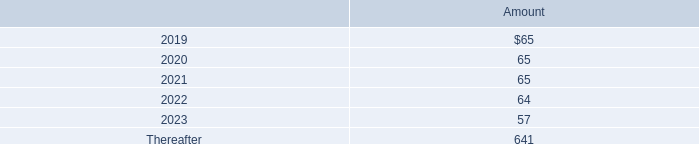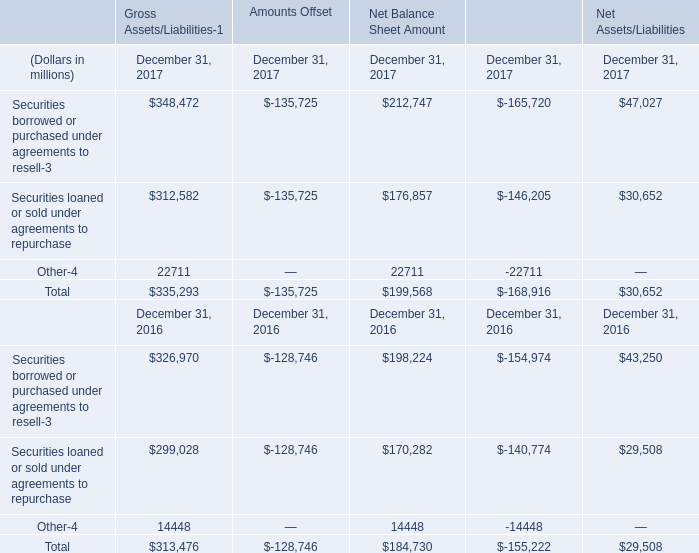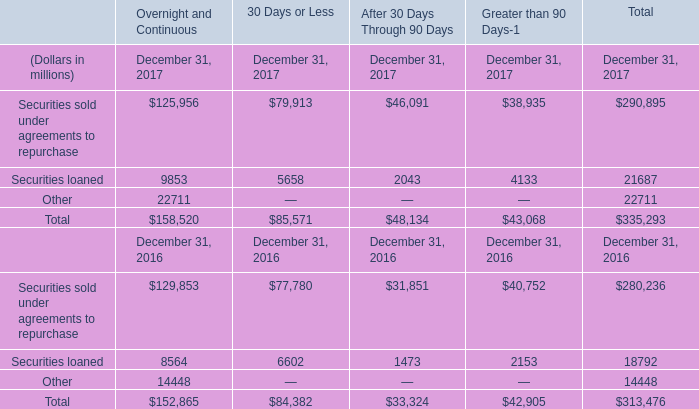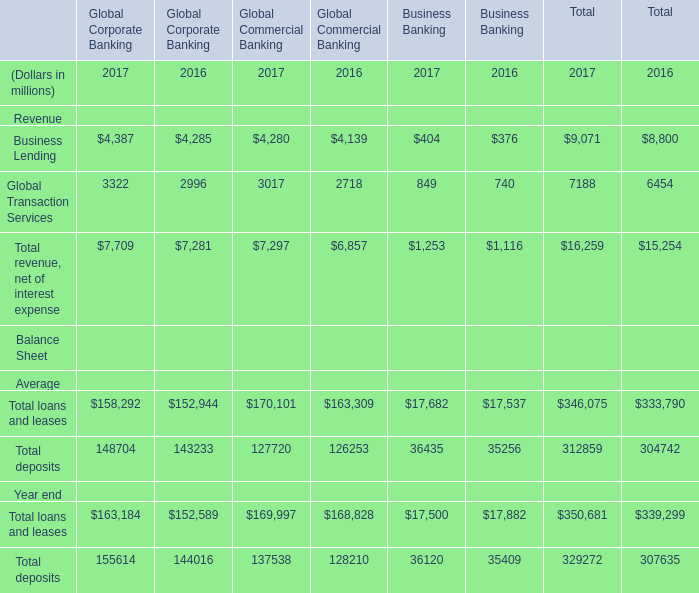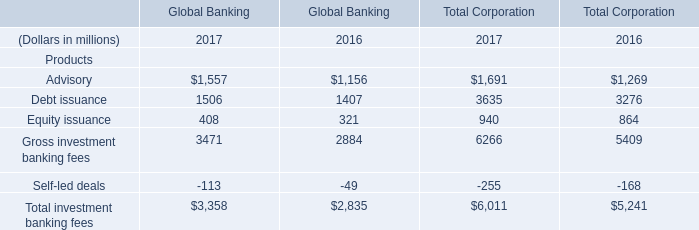If total revenue of business banking develops with the same growth rate in 2017, what will it reach in 2018? (in million) 
Computations: ((((1253 - 1116) / 1116) + 1) * 1253)
Answer: 1406.8181. 